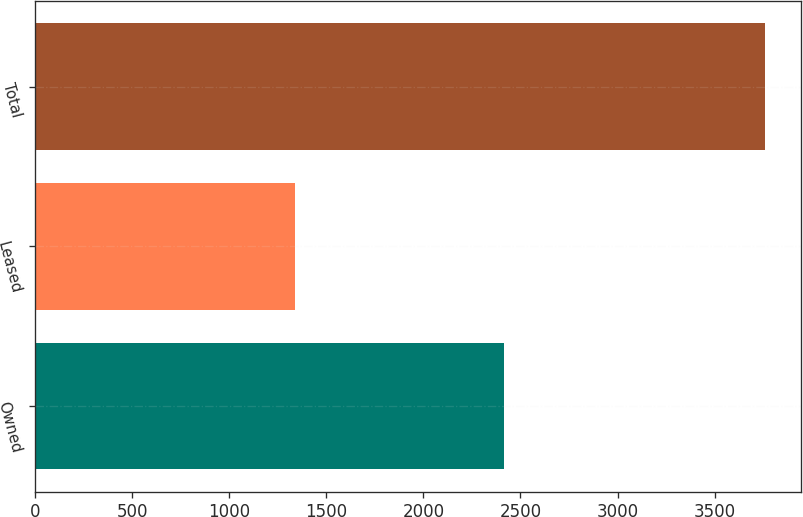<chart> <loc_0><loc_0><loc_500><loc_500><bar_chart><fcel>Owned<fcel>Leased<fcel>Total<nl><fcel>2417<fcel>1341<fcel>3758<nl></chart> 